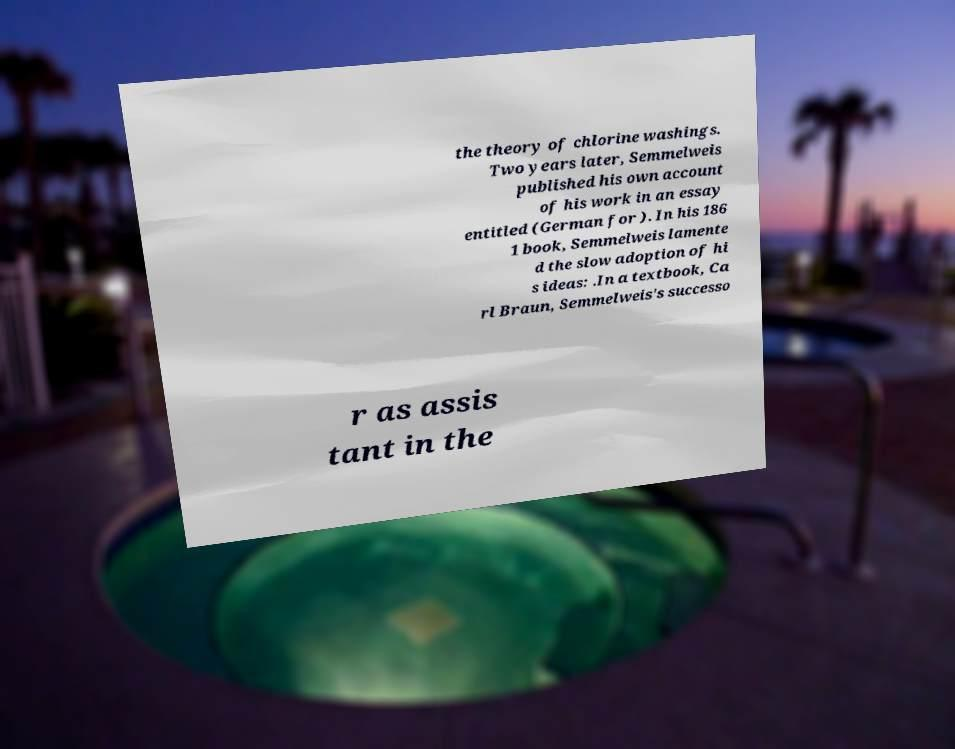There's text embedded in this image that I need extracted. Can you transcribe it verbatim? the theory of chlorine washings. Two years later, Semmelweis published his own account of his work in an essay entitled (German for ). In his 186 1 book, Semmelweis lamente d the slow adoption of hi s ideas: .In a textbook, Ca rl Braun, Semmelweis's successo r as assis tant in the 